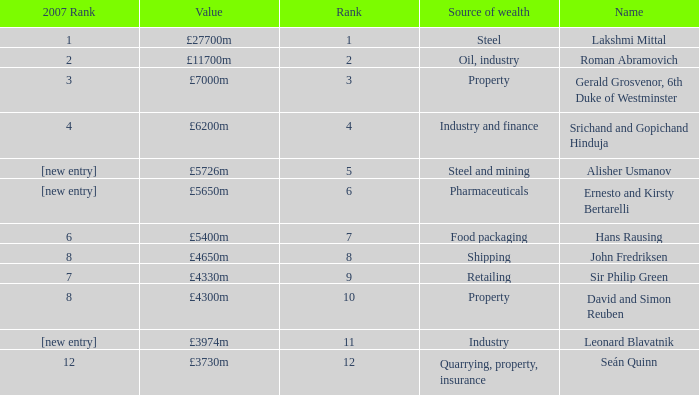What source of wealth has a value of £5726m? Steel and mining. 